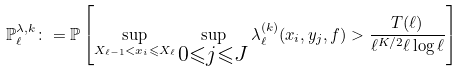Convert formula to latex. <formula><loc_0><loc_0><loc_500><loc_500>\mathbb { P } _ { \ell } ^ { \lambda , k } \colon = \mathbb { P } \left [ \sup _ { X _ { \ell - 1 } < x _ { i } \leqslant X _ { \ell } } \sup _ { \substack { 0 \leqslant j \leqslant J } } \lambda _ { \ell } ^ { ( k ) } ( x _ { i } , y _ { j } , f ) > \frac { T ( \ell ) } { \ell ^ { K / 2 } \ell \log \ell } \right ]</formula> 